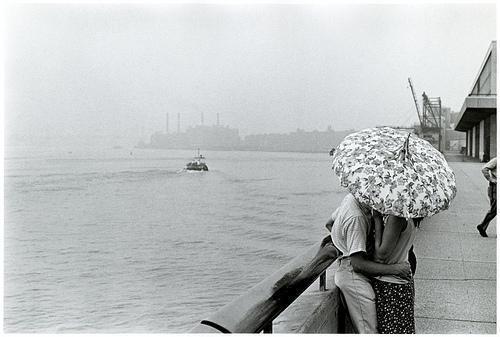How many people are in the photo?
Give a very brief answer. 2. How many horses are there?
Give a very brief answer. 0. 